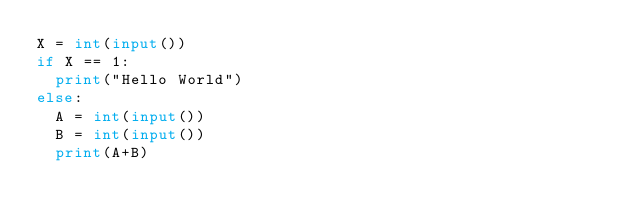<code> <loc_0><loc_0><loc_500><loc_500><_Python_>X = int(input())
if X == 1:
  print("Hello World")
else:
  A = int(input())
  B = int(input())
  print(A+B)</code> 